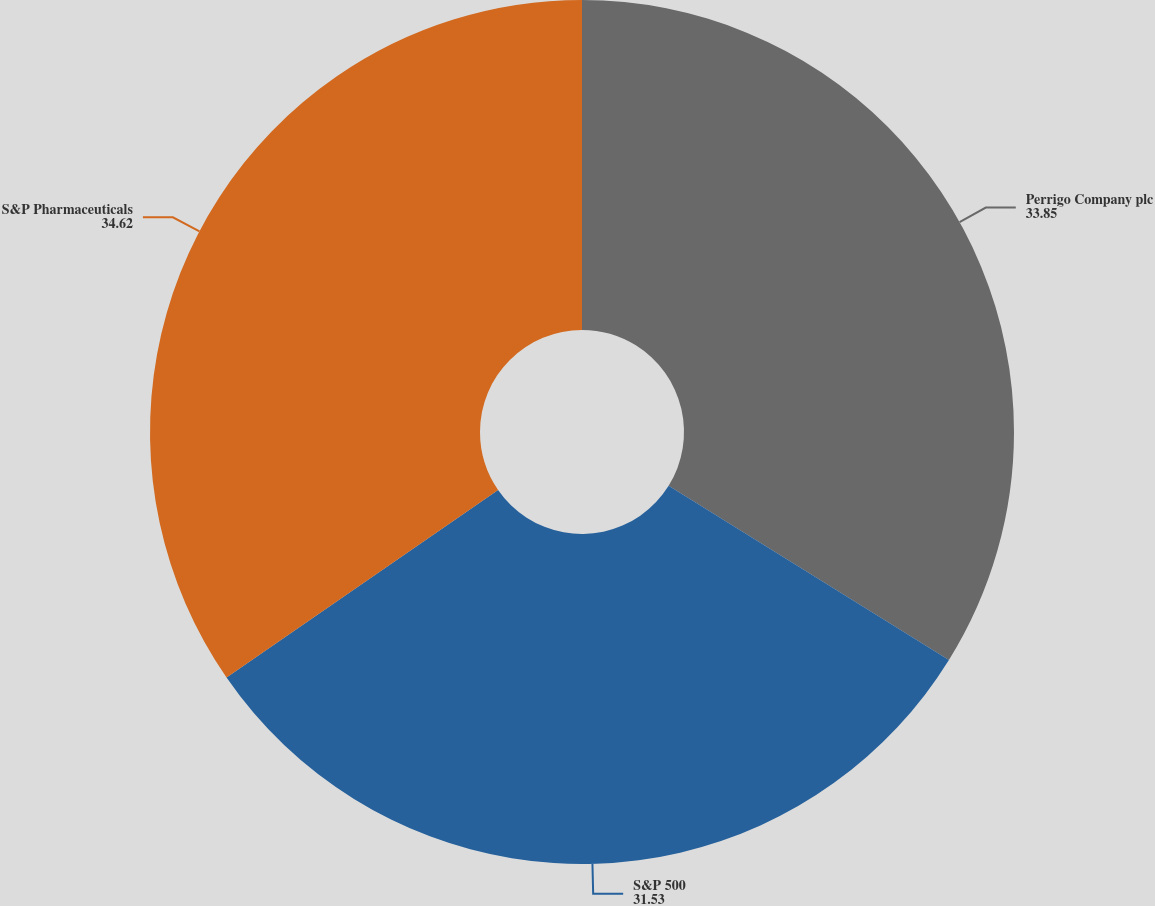Convert chart. <chart><loc_0><loc_0><loc_500><loc_500><pie_chart><fcel>Perrigo Company plc<fcel>S&P 500<fcel>S&P Pharmaceuticals<nl><fcel>33.85%<fcel>31.53%<fcel>34.62%<nl></chart> 